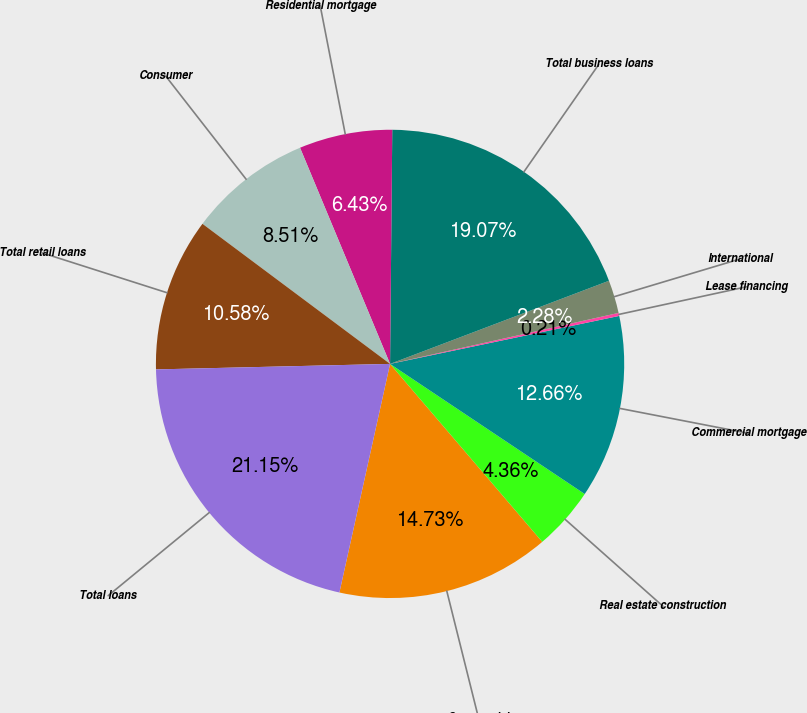Convert chart. <chart><loc_0><loc_0><loc_500><loc_500><pie_chart><fcel>Commercial<fcel>Real estate construction<fcel>Commercial mortgage<fcel>Lease financing<fcel>International<fcel>Total business loans<fcel>Residential mortgage<fcel>Consumer<fcel>Total retail loans<fcel>Total loans<nl><fcel>14.73%<fcel>4.36%<fcel>12.66%<fcel>0.21%<fcel>2.28%<fcel>19.07%<fcel>6.43%<fcel>8.51%<fcel>10.58%<fcel>21.15%<nl></chart> 